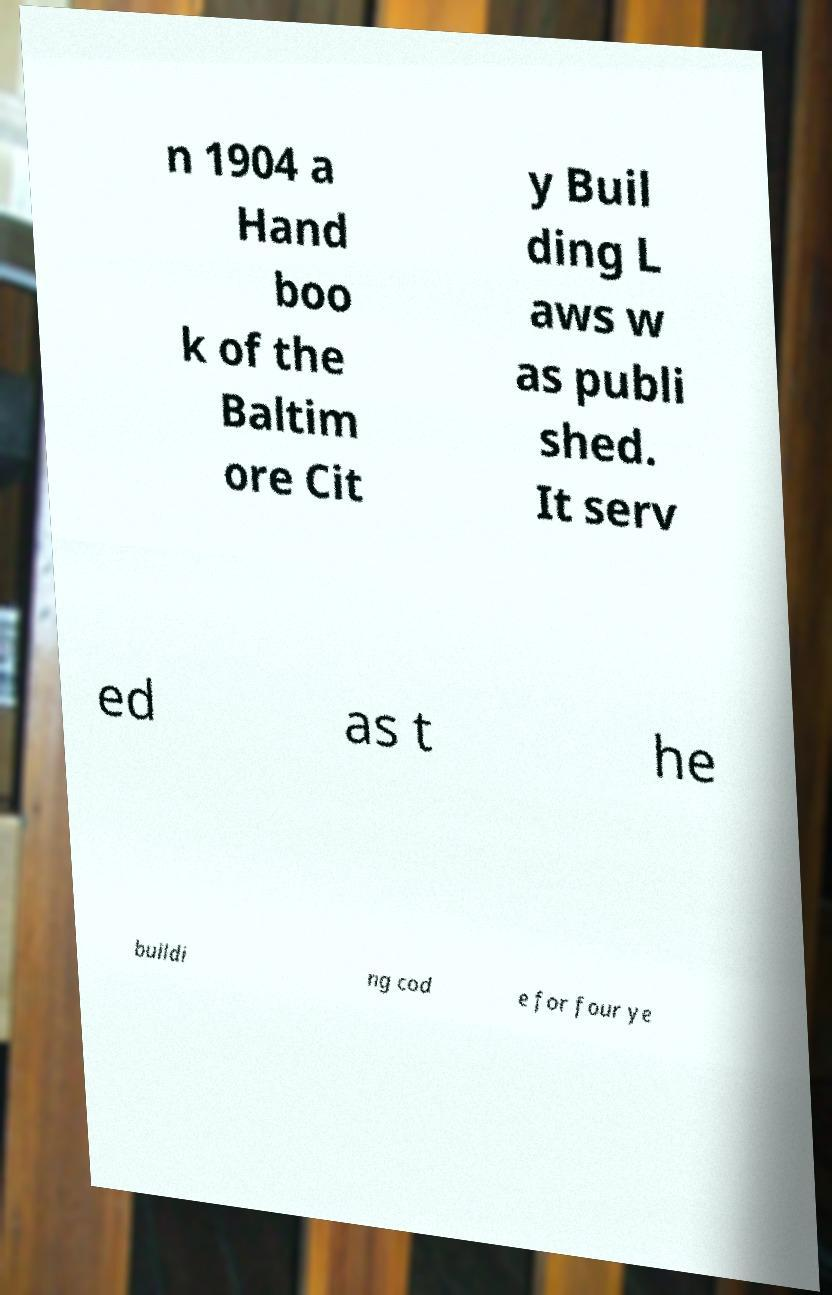What messages or text are displayed in this image? I need them in a readable, typed format. n 1904 a Hand boo k of the Baltim ore Cit y Buil ding L aws w as publi shed. It serv ed as t he buildi ng cod e for four ye 